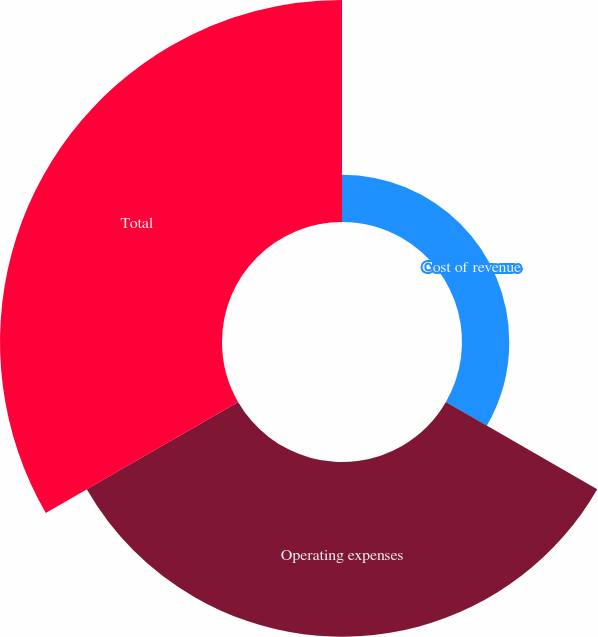<chart> <loc_0><loc_0><loc_500><loc_500><pie_chart><fcel>Cost of revenue<fcel>Operating expenses<fcel>Total<nl><fcel>10.65%<fcel>39.35%<fcel>50.0%<nl></chart> 